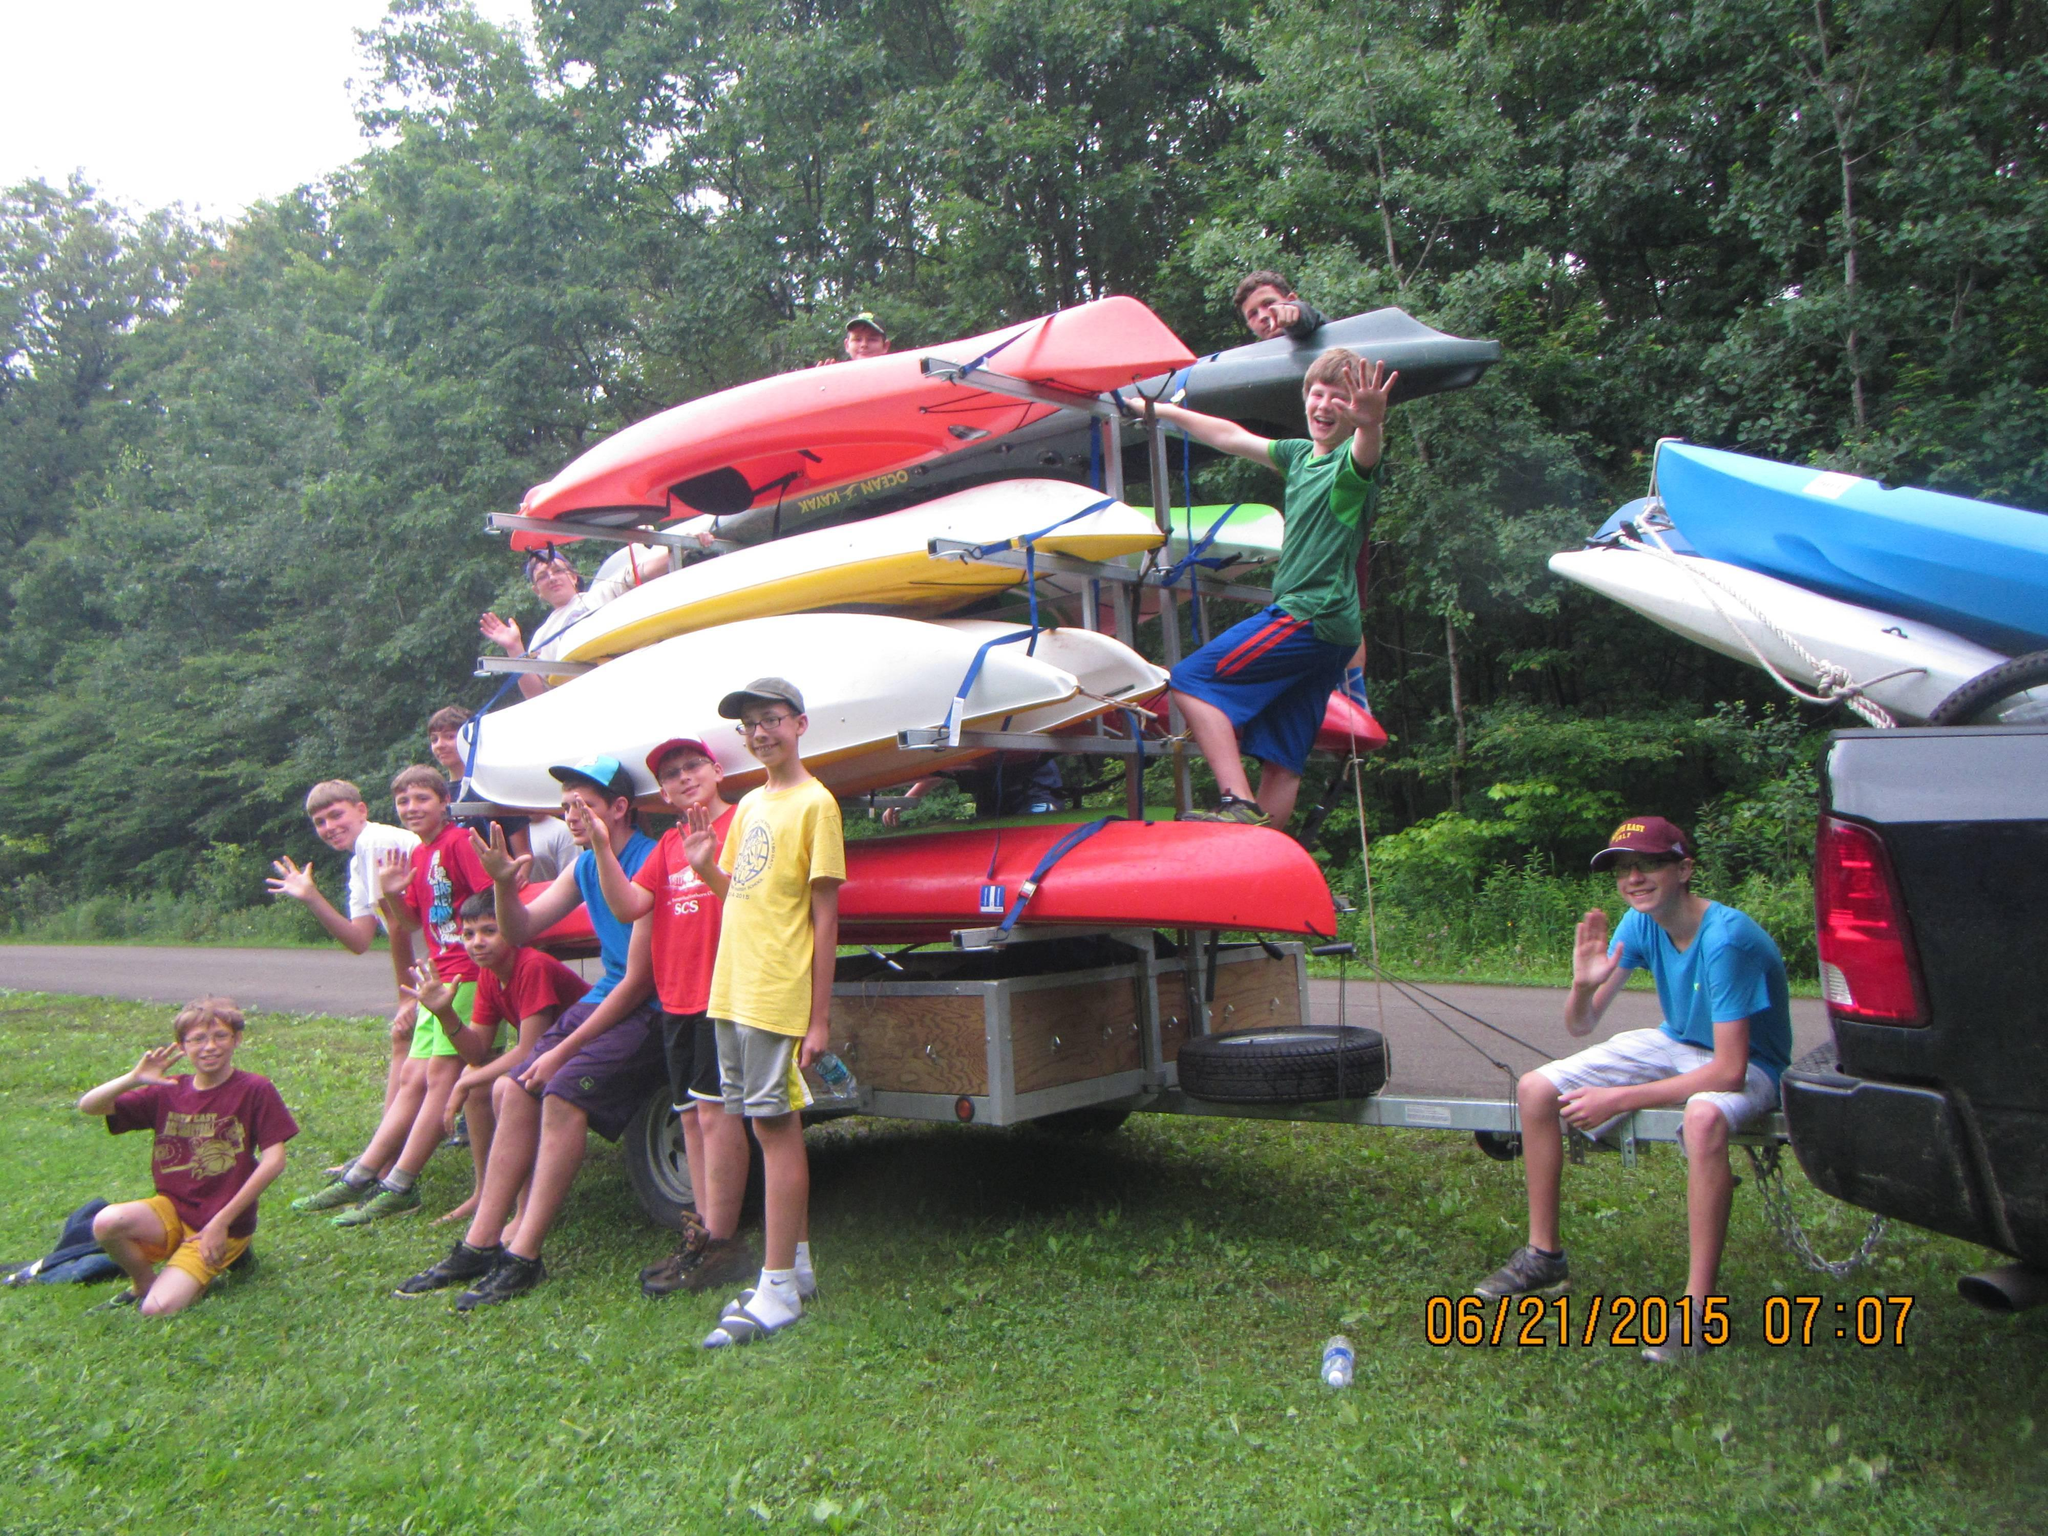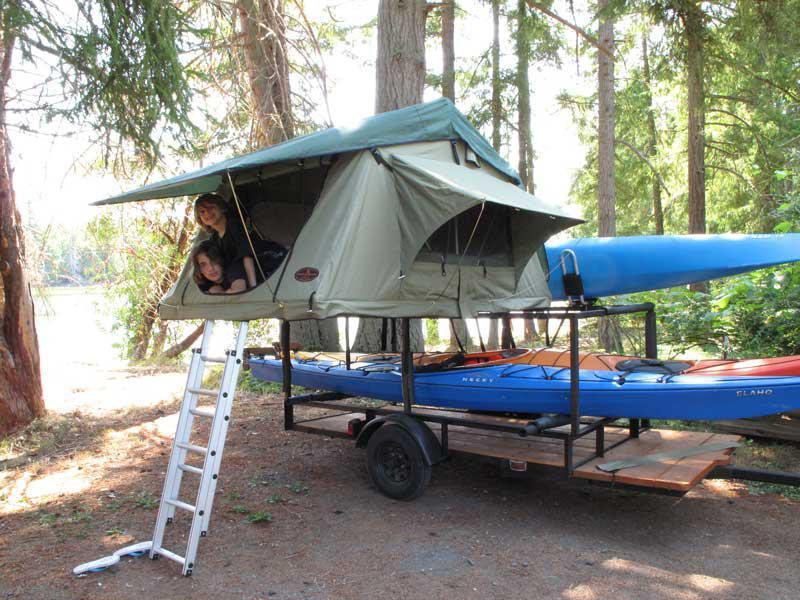The first image is the image on the left, the second image is the image on the right. Assess this claim about the two images: "An image shows two orange boats atop a trailer.". Correct or not? Answer yes or no. No. The first image is the image on the left, the second image is the image on the right. Assess this claim about the two images: "There are at least five canoes in the image on the left.". Correct or not? Answer yes or no. Yes. 